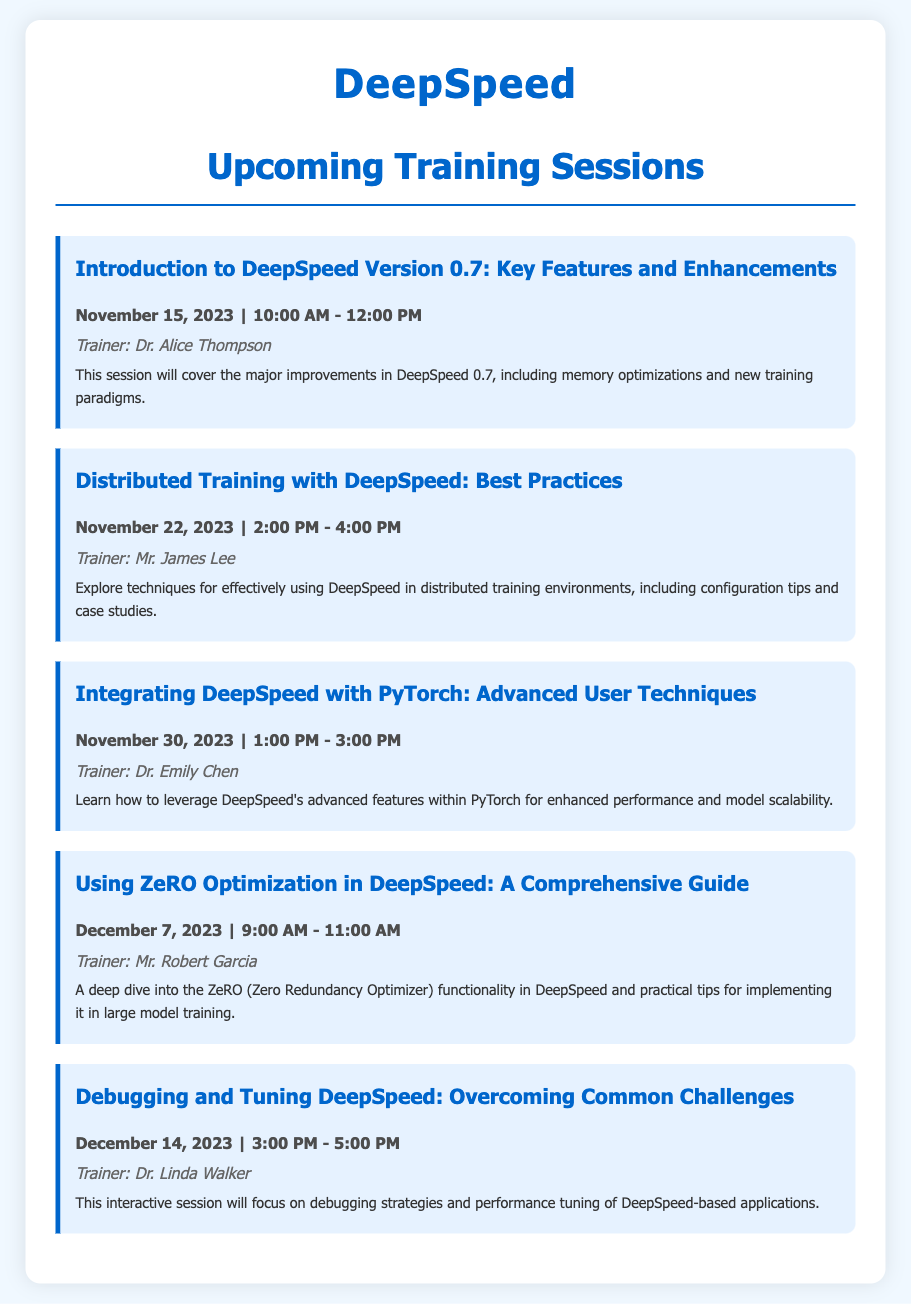What is the first training session title? The first training session is listed at the top of the document, which is focused on new features and enhancements in DeepSpeed.
Answer: Introduction to DeepSpeed Version 0.7: Key Features and Enhancements Who is the trainer for the session on December 14, 2023? The document lists the trainer for each session, and for December 14, the trainer is specified.
Answer: Dr. Linda Walker What is the date for the session on debugging and tuning DeepSpeed? Each session includes a date, and the specific date for the debugging session can be retrieved from the document.
Answer: December 14, 2023 How long is the session on integrating DeepSpeed with PyTorch? The duration of each session is mentioned alongside the date in the document.
Answer: 2 hours Which session covers ZeRO optimization? The document categorizes sessions, and identifying the session that focuses on ZeRO optimization reveals its title.
Answer: Using ZeRO Optimization in DeepSpeed: A Comprehensive Guide How many training sessions are listed in total? The document enumerates several sessions, which allows for counting them directly.
Answer: 5 sessions 